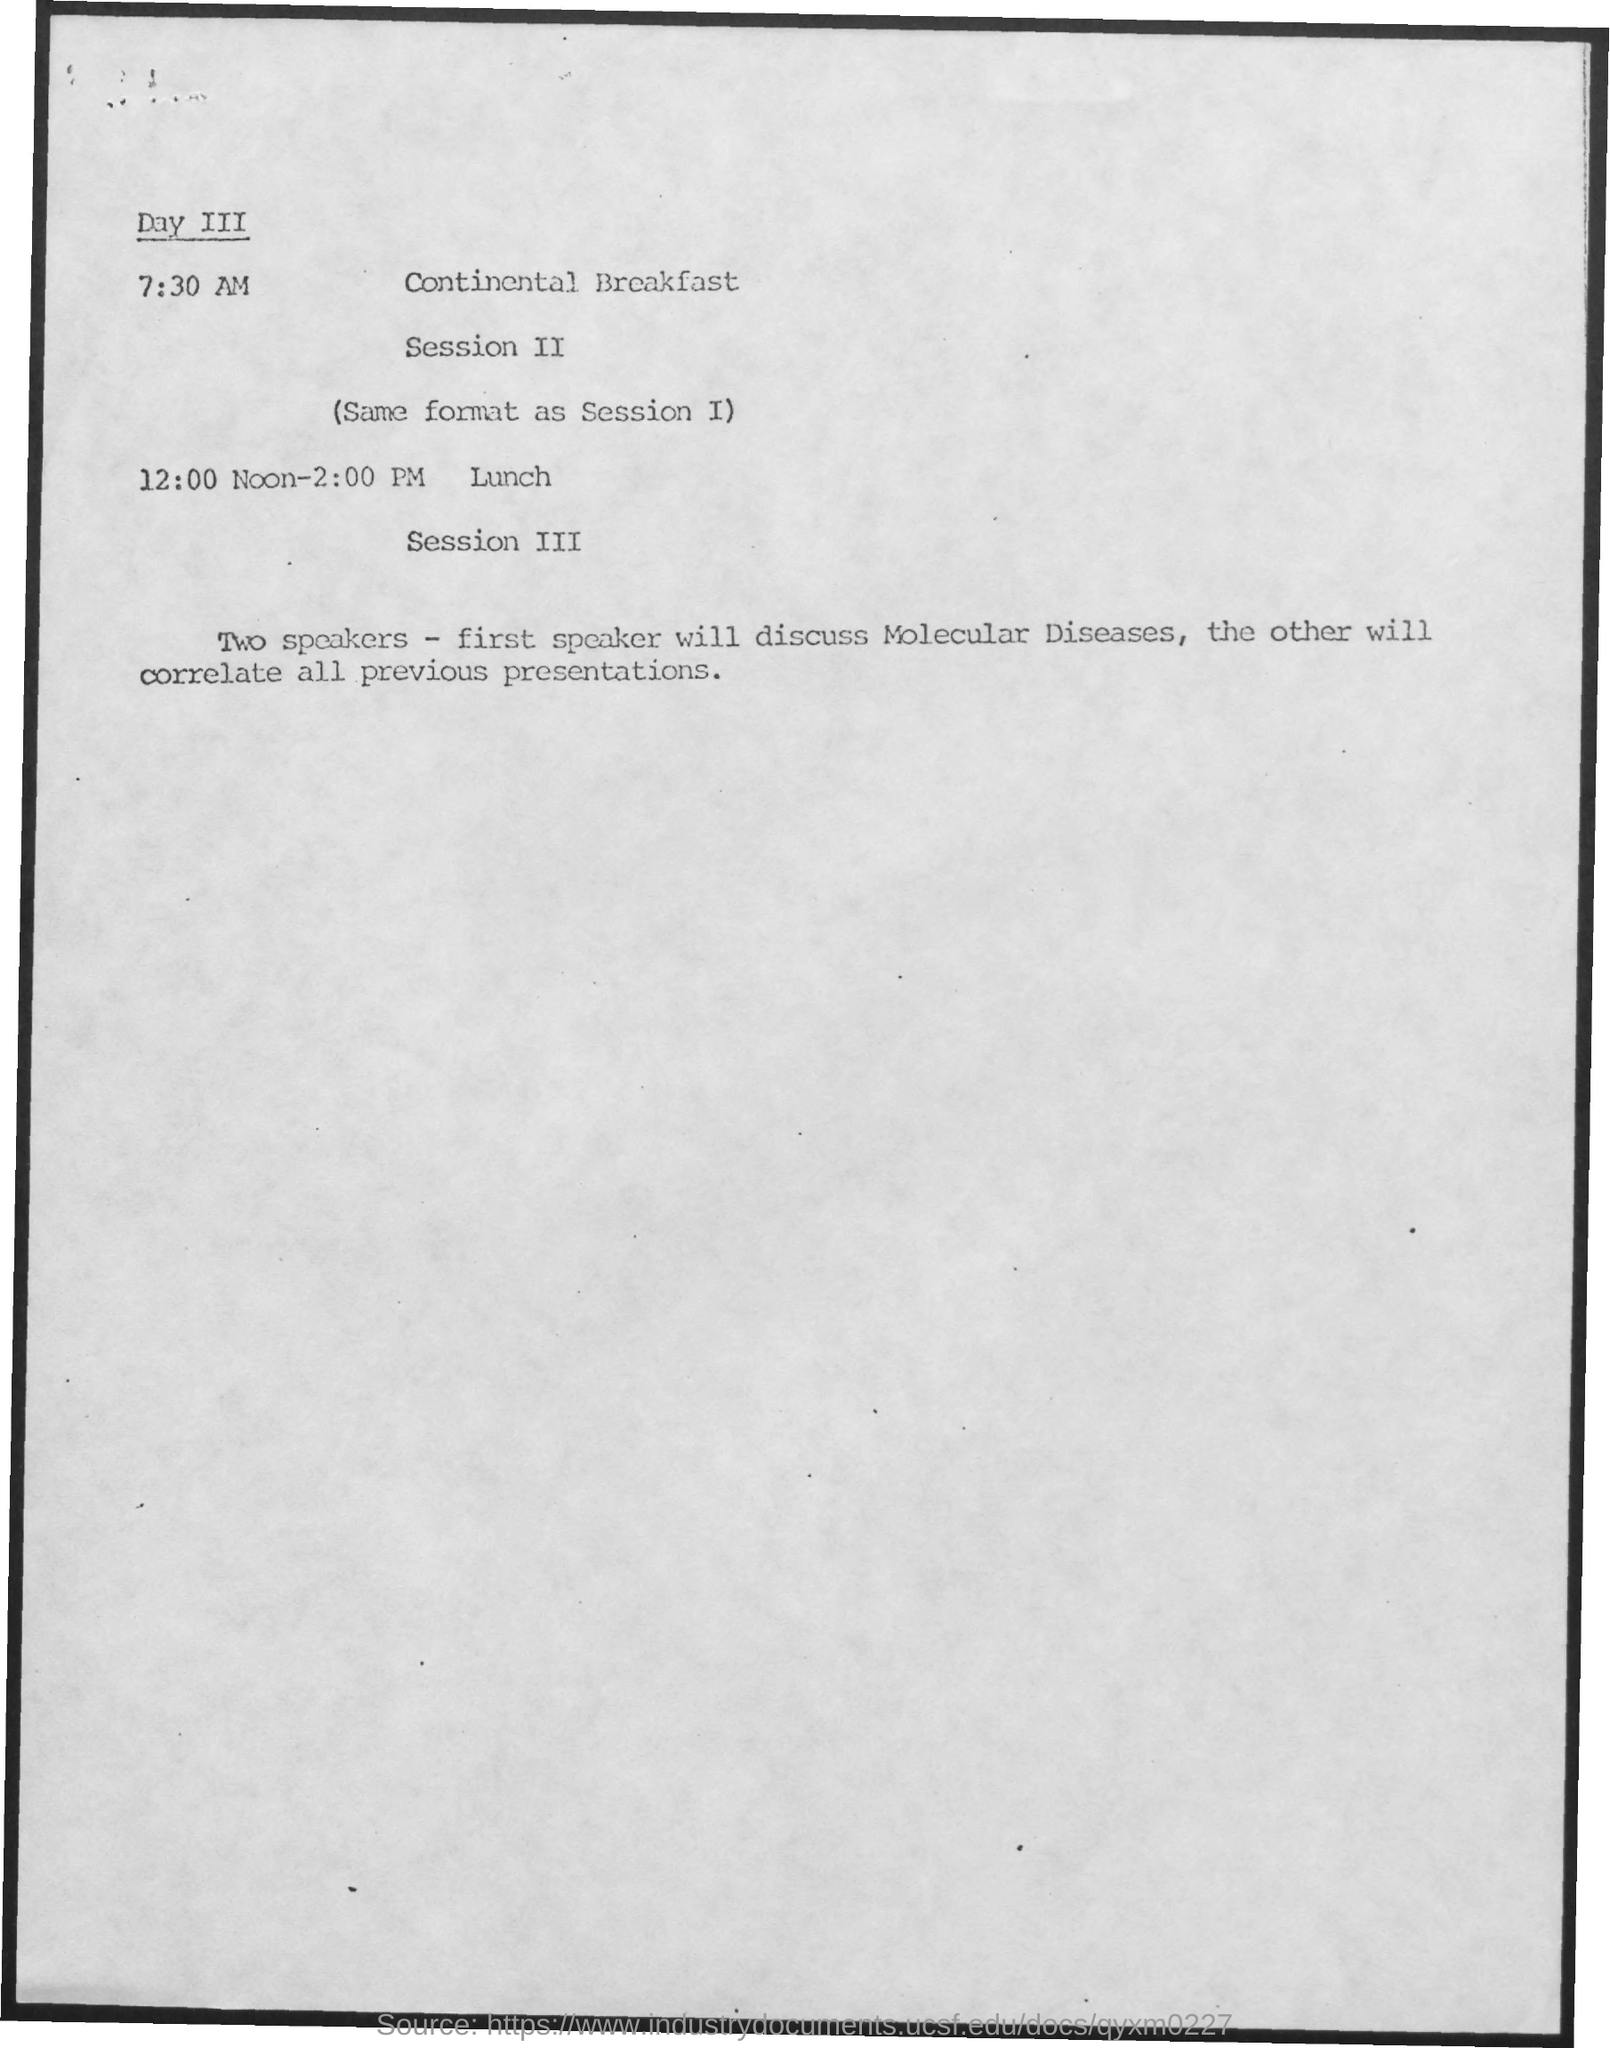Outline some significant characteristics in this image. At 7:30 AM, the schedule includes continental breakfast. At 12:00 noon to 2:00 pm, it is lunchtime. 